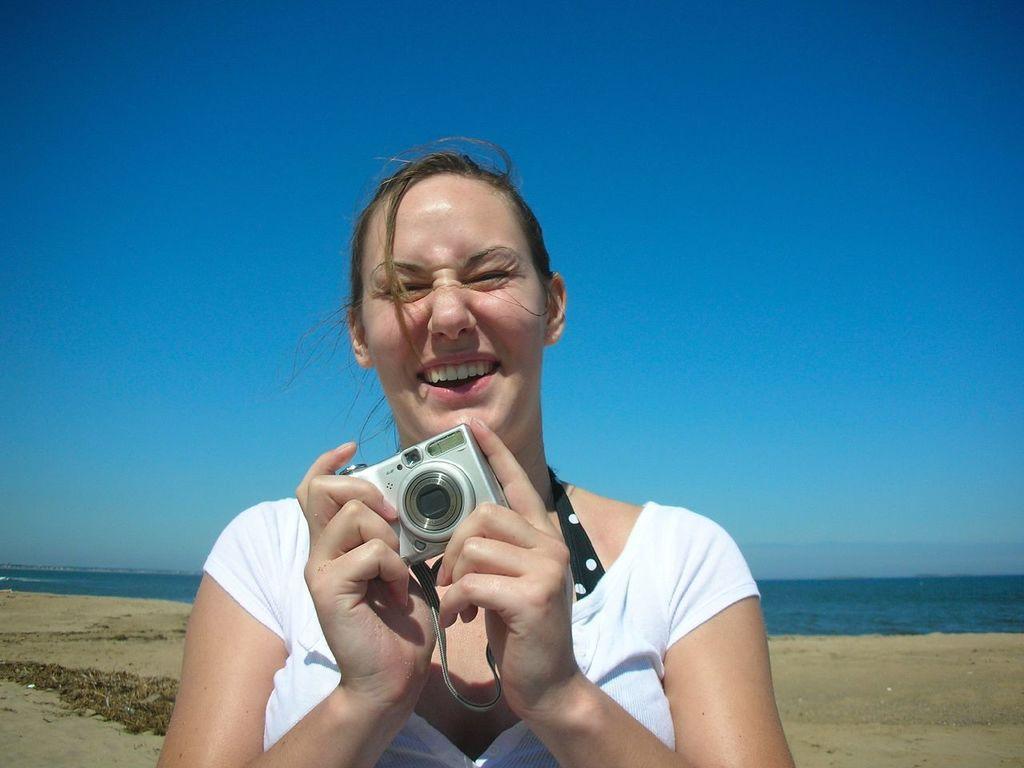Please provide a concise description of this image. In this image I see a woman who is holding a camera and she is smiling. In the background I see the sand, water and the sky. 